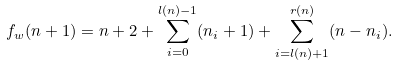Convert formula to latex. <formula><loc_0><loc_0><loc_500><loc_500>f _ { w } ( n + 1 ) = n + 2 + \sum _ { i = 0 } ^ { l ( n ) - 1 } ( n _ { i } + 1 ) + \sum _ { i = l ( n ) + 1 } ^ { r ( n ) } ( n - n _ { i } ) .</formula> 